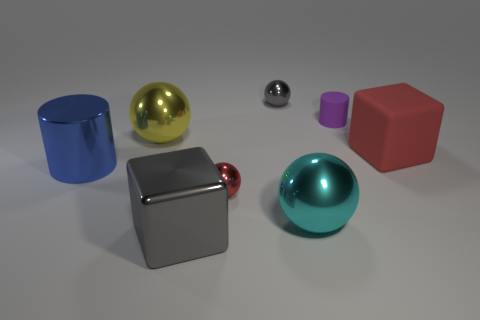Are there more big cylinders in front of the large gray cube than small gray metal blocks?
Your answer should be compact. No. The cube behind the cyan object is what color?
Give a very brief answer. Red. There is a metallic thing that is the same color as the large rubber thing; what is its size?
Your answer should be compact. Small. How many metallic objects are tiny cylinders or tiny spheres?
Your answer should be compact. 2. There is a big block behind the big cube in front of the large red block; is there a metallic object behind it?
Provide a succinct answer. Yes. How many small rubber things are in front of the purple cylinder?
Offer a very short reply. 0. What is the material of the small ball that is the same color as the big matte object?
Make the answer very short. Metal. How many large things are either shiny things or gray objects?
Your answer should be very brief. 4. There is a large red rubber object that is on the right side of the tiny red shiny object; what shape is it?
Keep it short and to the point. Cube. Are there any other objects of the same color as the large matte object?
Provide a succinct answer. Yes. 